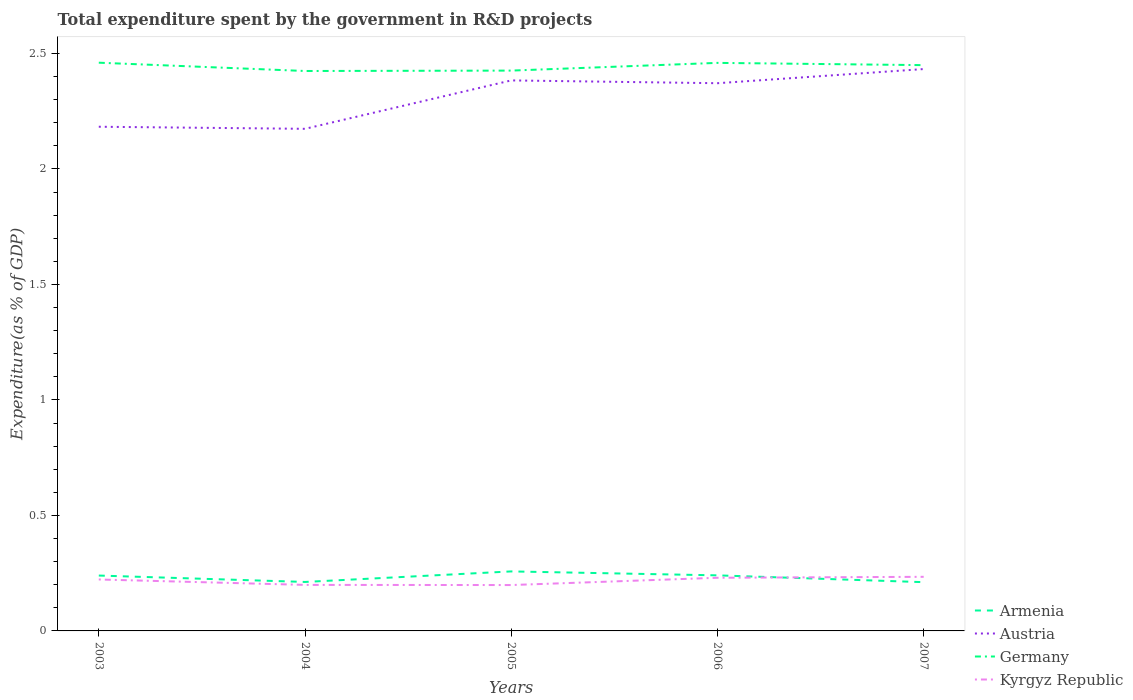How many different coloured lines are there?
Provide a succinct answer. 4. Does the line corresponding to Armenia intersect with the line corresponding to Kyrgyz Republic?
Give a very brief answer. Yes. Across all years, what is the maximum total expenditure spent by the government in R&D projects in Germany?
Give a very brief answer. 2.42. What is the total total expenditure spent by the government in R&D projects in Austria in the graph?
Your answer should be very brief. -0.25. What is the difference between the highest and the second highest total expenditure spent by the government in R&D projects in Kyrgyz Republic?
Your answer should be very brief. 0.04. Does the graph contain any zero values?
Your answer should be compact. No. Does the graph contain grids?
Provide a short and direct response. No. Where does the legend appear in the graph?
Give a very brief answer. Bottom right. What is the title of the graph?
Provide a succinct answer. Total expenditure spent by the government in R&D projects. Does "Thailand" appear as one of the legend labels in the graph?
Ensure brevity in your answer.  No. What is the label or title of the Y-axis?
Offer a terse response. Expenditure(as % of GDP). What is the Expenditure(as % of GDP) of Armenia in 2003?
Your answer should be compact. 0.24. What is the Expenditure(as % of GDP) of Austria in 2003?
Make the answer very short. 2.18. What is the Expenditure(as % of GDP) in Germany in 2003?
Provide a succinct answer. 2.46. What is the Expenditure(as % of GDP) of Kyrgyz Republic in 2003?
Your response must be concise. 0.22. What is the Expenditure(as % of GDP) of Armenia in 2004?
Provide a succinct answer. 0.21. What is the Expenditure(as % of GDP) in Austria in 2004?
Your answer should be compact. 2.17. What is the Expenditure(as % of GDP) of Germany in 2004?
Make the answer very short. 2.42. What is the Expenditure(as % of GDP) of Kyrgyz Republic in 2004?
Your answer should be compact. 0.2. What is the Expenditure(as % of GDP) of Armenia in 2005?
Offer a very short reply. 0.26. What is the Expenditure(as % of GDP) of Austria in 2005?
Give a very brief answer. 2.38. What is the Expenditure(as % of GDP) in Germany in 2005?
Offer a very short reply. 2.43. What is the Expenditure(as % of GDP) in Kyrgyz Republic in 2005?
Your answer should be compact. 0.2. What is the Expenditure(as % of GDP) of Armenia in 2006?
Provide a succinct answer. 0.24. What is the Expenditure(as % of GDP) in Austria in 2006?
Provide a succinct answer. 2.37. What is the Expenditure(as % of GDP) of Germany in 2006?
Provide a succinct answer. 2.46. What is the Expenditure(as % of GDP) in Kyrgyz Republic in 2006?
Give a very brief answer. 0.23. What is the Expenditure(as % of GDP) in Armenia in 2007?
Your answer should be compact. 0.21. What is the Expenditure(as % of GDP) of Austria in 2007?
Offer a very short reply. 2.43. What is the Expenditure(as % of GDP) of Germany in 2007?
Give a very brief answer. 2.45. What is the Expenditure(as % of GDP) of Kyrgyz Republic in 2007?
Provide a succinct answer. 0.23. Across all years, what is the maximum Expenditure(as % of GDP) in Armenia?
Provide a succinct answer. 0.26. Across all years, what is the maximum Expenditure(as % of GDP) in Austria?
Provide a succinct answer. 2.43. Across all years, what is the maximum Expenditure(as % of GDP) in Germany?
Your answer should be very brief. 2.46. Across all years, what is the maximum Expenditure(as % of GDP) in Kyrgyz Republic?
Your answer should be very brief. 0.23. Across all years, what is the minimum Expenditure(as % of GDP) in Armenia?
Your answer should be compact. 0.21. Across all years, what is the minimum Expenditure(as % of GDP) in Austria?
Keep it short and to the point. 2.17. Across all years, what is the minimum Expenditure(as % of GDP) of Germany?
Provide a succinct answer. 2.42. Across all years, what is the minimum Expenditure(as % of GDP) in Kyrgyz Republic?
Ensure brevity in your answer.  0.2. What is the total Expenditure(as % of GDP) of Armenia in the graph?
Offer a very short reply. 1.16. What is the total Expenditure(as % of GDP) of Austria in the graph?
Ensure brevity in your answer.  11.54. What is the total Expenditure(as % of GDP) of Germany in the graph?
Offer a very short reply. 12.22. What is the total Expenditure(as % of GDP) of Kyrgyz Republic in the graph?
Make the answer very short. 1.08. What is the difference between the Expenditure(as % of GDP) in Armenia in 2003 and that in 2004?
Your response must be concise. 0.03. What is the difference between the Expenditure(as % of GDP) in Austria in 2003 and that in 2004?
Offer a terse response. 0.01. What is the difference between the Expenditure(as % of GDP) of Germany in 2003 and that in 2004?
Ensure brevity in your answer.  0.04. What is the difference between the Expenditure(as % of GDP) of Kyrgyz Republic in 2003 and that in 2004?
Provide a short and direct response. 0.02. What is the difference between the Expenditure(as % of GDP) in Armenia in 2003 and that in 2005?
Provide a short and direct response. -0.02. What is the difference between the Expenditure(as % of GDP) of Austria in 2003 and that in 2005?
Give a very brief answer. -0.2. What is the difference between the Expenditure(as % of GDP) of Germany in 2003 and that in 2005?
Offer a terse response. 0.03. What is the difference between the Expenditure(as % of GDP) of Kyrgyz Republic in 2003 and that in 2005?
Offer a very short reply. 0.02. What is the difference between the Expenditure(as % of GDP) of Armenia in 2003 and that in 2006?
Provide a short and direct response. -0. What is the difference between the Expenditure(as % of GDP) of Austria in 2003 and that in 2006?
Your answer should be very brief. -0.19. What is the difference between the Expenditure(as % of GDP) in Germany in 2003 and that in 2006?
Ensure brevity in your answer.  0. What is the difference between the Expenditure(as % of GDP) in Kyrgyz Republic in 2003 and that in 2006?
Your response must be concise. -0.01. What is the difference between the Expenditure(as % of GDP) of Armenia in 2003 and that in 2007?
Offer a very short reply. 0.03. What is the difference between the Expenditure(as % of GDP) in Austria in 2003 and that in 2007?
Give a very brief answer. -0.25. What is the difference between the Expenditure(as % of GDP) of Germany in 2003 and that in 2007?
Provide a short and direct response. 0.01. What is the difference between the Expenditure(as % of GDP) in Kyrgyz Republic in 2003 and that in 2007?
Your answer should be compact. -0.01. What is the difference between the Expenditure(as % of GDP) in Armenia in 2004 and that in 2005?
Your response must be concise. -0.05. What is the difference between the Expenditure(as % of GDP) of Austria in 2004 and that in 2005?
Offer a very short reply. -0.21. What is the difference between the Expenditure(as % of GDP) of Germany in 2004 and that in 2005?
Make the answer very short. -0. What is the difference between the Expenditure(as % of GDP) in Kyrgyz Republic in 2004 and that in 2005?
Offer a terse response. 0. What is the difference between the Expenditure(as % of GDP) of Armenia in 2004 and that in 2006?
Provide a short and direct response. -0.03. What is the difference between the Expenditure(as % of GDP) in Austria in 2004 and that in 2006?
Make the answer very short. -0.2. What is the difference between the Expenditure(as % of GDP) in Germany in 2004 and that in 2006?
Offer a very short reply. -0.04. What is the difference between the Expenditure(as % of GDP) in Kyrgyz Republic in 2004 and that in 2006?
Make the answer very short. -0.03. What is the difference between the Expenditure(as % of GDP) in Armenia in 2004 and that in 2007?
Your answer should be very brief. 0. What is the difference between the Expenditure(as % of GDP) in Austria in 2004 and that in 2007?
Provide a short and direct response. -0.26. What is the difference between the Expenditure(as % of GDP) of Germany in 2004 and that in 2007?
Ensure brevity in your answer.  -0.03. What is the difference between the Expenditure(as % of GDP) of Kyrgyz Republic in 2004 and that in 2007?
Provide a short and direct response. -0.04. What is the difference between the Expenditure(as % of GDP) in Armenia in 2005 and that in 2006?
Make the answer very short. 0.02. What is the difference between the Expenditure(as % of GDP) in Austria in 2005 and that in 2006?
Ensure brevity in your answer.  0.01. What is the difference between the Expenditure(as % of GDP) of Germany in 2005 and that in 2006?
Provide a short and direct response. -0.03. What is the difference between the Expenditure(as % of GDP) in Kyrgyz Republic in 2005 and that in 2006?
Give a very brief answer. -0.03. What is the difference between the Expenditure(as % of GDP) of Armenia in 2005 and that in 2007?
Your answer should be very brief. 0.05. What is the difference between the Expenditure(as % of GDP) in Austria in 2005 and that in 2007?
Ensure brevity in your answer.  -0.05. What is the difference between the Expenditure(as % of GDP) of Germany in 2005 and that in 2007?
Provide a succinct answer. -0.02. What is the difference between the Expenditure(as % of GDP) of Kyrgyz Republic in 2005 and that in 2007?
Make the answer very short. -0.04. What is the difference between the Expenditure(as % of GDP) of Armenia in 2006 and that in 2007?
Offer a terse response. 0.03. What is the difference between the Expenditure(as % of GDP) in Austria in 2006 and that in 2007?
Your answer should be very brief. -0.06. What is the difference between the Expenditure(as % of GDP) in Germany in 2006 and that in 2007?
Ensure brevity in your answer.  0.01. What is the difference between the Expenditure(as % of GDP) in Kyrgyz Republic in 2006 and that in 2007?
Make the answer very short. -0. What is the difference between the Expenditure(as % of GDP) in Armenia in 2003 and the Expenditure(as % of GDP) in Austria in 2004?
Your answer should be very brief. -1.93. What is the difference between the Expenditure(as % of GDP) of Armenia in 2003 and the Expenditure(as % of GDP) of Germany in 2004?
Offer a very short reply. -2.18. What is the difference between the Expenditure(as % of GDP) in Armenia in 2003 and the Expenditure(as % of GDP) in Kyrgyz Republic in 2004?
Your answer should be compact. 0.04. What is the difference between the Expenditure(as % of GDP) of Austria in 2003 and the Expenditure(as % of GDP) of Germany in 2004?
Offer a terse response. -0.24. What is the difference between the Expenditure(as % of GDP) in Austria in 2003 and the Expenditure(as % of GDP) in Kyrgyz Republic in 2004?
Offer a terse response. 1.98. What is the difference between the Expenditure(as % of GDP) in Germany in 2003 and the Expenditure(as % of GDP) in Kyrgyz Republic in 2004?
Offer a very short reply. 2.26. What is the difference between the Expenditure(as % of GDP) in Armenia in 2003 and the Expenditure(as % of GDP) in Austria in 2005?
Make the answer very short. -2.14. What is the difference between the Expenditure(as % of GDP) of Armenia in 2003 and the Expenditure(as % of GDP) of Germany in 2005?
Provide a succinct answer. -2.19. What is the difference between the Expenditure(as % of GDP) in Armenia in 2003 and the Expenditure(as % of GDP) in Kyrgyz Republic in 2005?
Offer a terse response. 0.04. What is the difference between the Expenditure(as % of GDP) in Austria in 2003 and the Expenditure(as % of GDP) in Germany in 2005?
Your response must be concise. -0.24. What is the difference between the Expenditure(as % of GDP) of Austria in 2003 and the Expenditure(as % of GDP) of Kyrgyz Republic in 2005?
Give a very brief answer. 1.98. What is the difference between the Expenditure(as % of GDP) in Germany in 2003 and the Expenditure(as % of GDP) in Kyrgyz Republic in 2005?
Ensure brevity in your answer.  2.26. What is the difference between the Expenditure(as % of GDP) of Armenia in 2003 and the Expenditure(as % of GDP) of Austria in 2006?
Ensure brevity in your answer.  -2.13. What is the difference between the Expenditure(as % of GDP) of Armenia in 2003 and the Expenditure(as % of GDP) of Germany in 2006?
Provide a succinct answer. -2.22. What is the difference between the Expenditure(as % of GDP) in Armenia in 2003 and the Expenditure(as % of GDP) in Kyrgyz Republic in 2006?
Offer a terse response. 0.01. What is the difference between the Expenditure(as % of GDP) in Austria in 2003 and the Expenditure(as % of GDP) in Germany in 2006?
Give a very brief answer. -0.28. What is the difference between the Expenditure(as % of GDP) of Austria in 2003 and the Expenditure(as % of GDP) of Kyrgyz Republic in 2006?
Your response must be concise. 1.95. What is the difference between the Expenditure(as % of GDP) in Germany in 2003 and the Expenditure(as % of GDP) in Kyrgyz Republic in 2006?
Make the answer very short. 2.23. What is the difference between the Expenditure(as % of GDP) of Armenia in 2003 and the Expenditure(as % of GDP) of Austria in 2007?
Your answer should be very brief. -2.19. What is the difference between the Expenditure(as % of GDP) in Armenia in 2003 and the Expenditure(as % of GDP) in Germany in 2007?
Keep it short and to the point. -2.21. What is the difference between the Expenditure(as % of GDP) in Armenia in 2003 and the Expenditure(as % of GDP) in Kyrgyz Republic in 2007?
Offer a terse response. 0.01. What is the difference between the Expenditure(as % of GDP) in Austria in 2003 and the Expenditure(as % of GDP) in Germany in 2007?
Give a very brief answer. -0.27. What is the difference between the Expenditure(as % of GDP) of Austria in 2003 and the Expenditure(as % of GDP) of Kyrgyz Republic in 2007?
Offer a very short reply. 1.95. What is the difference between the Expenditure(as % of GDP) in Germany in 2003 and the Expenditure(as % of GDP) in Kyrgyz Republic in 2007?
Provide a short and direct response. 2.23. What is the difference between the Expenditure(as % of GDP) in Armenia in 2004 and the Expenditure(as % of GDP) in Austria in 2005?
Your answer should be very brief. -2.17. What is the difference between the Expenditure(as % of GDP) of Armenia in 2004 and the Expenditure(as % of GDP) of Germany in 2005?
Your answer should be compact. -2.21. What is the difference between the Expenditure(as % of GDP) of Armenia in 2004 and the Expenditure(as % of GDP) of Kyrgyz Republic in 2005?
Ensure brevity in your answer.  0.01. What is the difference between the Expenditure(as % of GDP) in Austria in 2004 and the Expenditure(as % of GDP) in Germany in 2005?
Keep it short and to the point. -0.25. What is the difference between the Expenditure(as % of GDP) in Austria in 2004 and the Expenditure(as % of GDP) in Kyrgyz Republic in 2005?
Make the answer very short. 1.98. What is the difference between the Expenditure(as % of GDP) of Germany in 2004 and the Expenditure(as % of GDP) of Kyrgyz Republic in 2005?
Offer a very short reply. 2.23. What is the difference between the Expenditure(as % of GDP) in Armenia in 2004 and the Expenditure(as % of GDP) in Austria in 2006?
Your answer should be compact. -2.16. What is the difference between the Expenditure(as % of GDP) in Armenia in 2004 and the Expenditure(as % of GDP) in Germany in 2006?
Provide a short and direct response. -2.25. What is the difference between the Expenditure(as % of GDP) of Armenia in 2004 and the Expenditure(as % of GDP) of Kyrgyz Republic in 2006?
Your answer should be compact. -0.02. What is the difference between the Expenditure(as % of GDP) in Austria in 2004 and the Expenditure(as % of GDP) in Germany in 2006?
Ensure brevity in your answer.  -0.29. What is the difference between the Expenditure(as % of GDP) in Austria in 2004 and the Expenditure(as % of GDP) in Kyrgyz Republic in 2006?
Give a very brief answer. 1.94. What is the difference between the Expenditure(as % of GDP) of Germany in 2004 and the Expenditure(as % of GDP) of Kyrgyz Republic in 2006?
Make the answer very short. 2.19. What is the difference between the Expenditure(as % of GDP) in Armenia in 2004 and the Expenditure(as % of GDP) in Austria in 2007?
Provide a succinct answer. -2.22. What is the difference between the Expenditure(as % of GDP) in Armenia in 2004 and the Expenditure(as % of GDP) in Germany in 2007?
Give a very brief answer. -2.24. What is the difference between the Expenditure(as % of GDP) of Armenia in 2004 and the Expenditure(as % of GDP) of Kyrgyz Republic in 2007?
Make the answer very short. -0.02. What is the difference between the Expenditure(as % of GDP) of Austria in 2004 and the Expenditure(as % of GDP) of Germany in 2007?
Your response must be concise. -0.28. What is the difference between the Expenditure(as % of GDP) of Austria in 2004 and the Expenditure(as % of GDP) of Kyrgyz Republic in 2007?
Your answer should be compact. 1.94. What is the difference between the Expenditure(as % of GDP) of Germany in 2004 and the Expenditure(as % of GDP) of Kyrgyz Republic in 2007?
Make the answer very short. 2.19. What is the difference between the Expenditure(as % of GDP) of Armenia in 2005 and the Expenditure(as % of GDP) of Austria in 2006?
Your answer should be compact. -2.11. What is the difference between the Expenditure(as % of GDP) of Armenia in 2005 and the Expenditure(as % of GDP) of Germany in 2006?
Ensure brevity in your answer.  -2.2. What is the difference between the Expenditure(as % of GDP) in Armenia in 2005 and the Expenditure(as % of GDP) in Kyrgyz Republic in 2006?
Provide a short and direct response. 0.03. What is the difference between the Expenditure(as % of GDP) in Austria in 2005 and the Expenditure(as % of GDP) in Germany in 2006?
Keep it short and to the point. -0.08. What is the difference between the Expenditure(as % of GDP) in Austria in 2005 and the Expenditure(as % of GDP) in Kyrgyz Republic in 2006?
Make the answer very short. 2.15. What is the difference between the Expenditure(as % of GDP) in Germany in 2005 and the Expenditure(as % of GDP) in Kyrgyz Republic in 2006?
Offer a very short reply. 2.2. What is the difference between the Expenditure(as % of GDP) in Armenia in 2005 and the Expenditure(as % of GDP) in Austria in 2007?
Keep it short and to the point. -2.17. What is the difference between the Expenditure(as % of GDP) in Armenia in 2005 and the Expenditure(as % of GDP) in Germany in 2007?
Your answer should be very brief. -2.19. What is the difference between the Expenditure(as % of GDP) of Armenia in 2005 and the Expenditure(as % of GDP) of Kyrgyz Republic in 2007?
Your answer should be compact. 0.02. What is the difference between the Expenditure(as % of GDP) in Austria in 2005 and the Expenditure(as % of GDP) in Germany in 2007?
Your response must be concise. -0.07. What is the difference between the Expenditure(as % of GDP) in Austria in 2005 and the Expenditure(as % of GDP) in Kyrgyz Republic in 2007?
Ensure brevity in your answer.  2.15. What is the difference between the Expenditure(as % of GDP) of Germany in 2005 and the Expenditure(as % of GDP) of Kyrgyz Republic in 2007?
Your answer should be compact. 2.19. What is the difference between the Expenditure(as % of GDP) of Armenia in 2006 and the Expenditure(as % of GDP) of Austria in 2007?
Offer a very short reply. -2.19. What is the difference between the Expenditure(as % of GDP) in Armenia in 2006 and the Expenditure(as % of GDP) in Germany in 2007?
Your answer should be very brief. -2.21. What is the difference between the Expenditure(as % of GDP) in Armenia in 2006 and the Expenditure(as % of GDP) in Kyrgyz Republic in 2007?
Your answer should be compact. 0.01. What is the difference between the Expenditure(as % of GDP) in Austria in 2006 and the Expenditure(as % of GDP) in Germany in 2007?
Keep it short and to the point. -0.08. What is the difference between the Expenditure(as % of GDP) of Austria in 2006 and the Expenditure(as % of GDP) of Kyrgyz Republic in 2007?
Provide a succinct answer. 2.14. What is the difference between the Expenditure(as % of GDP) in Germany in 2006 and the Expenditure(as % of GDP) in Kyrgyz Republic in 2007?
Your answer should be compact. 2.22. What is the average Expenditure(as % of GDP) of Armenia per year?
Ensure brevity in your answer.  0.23. What is the average Expenditure(as % of GDP) of Austria per year?
Make the answer very short. 2.31. What is the average Expenditure(as % of GDP) of Germany per year?
Keep it short and to the point. 2.44. What is the average Expenditure(as % of GDP) in Kyrgyz Republic per year?
Offer a very short reply. 0.22. In the year 2003, what is the difference between the Expenditure(as % of GDP) in Armenia and Expenditure(as % of GDP) in Austria?
Your answer should be compact. -1.94. In the year 2003, what is the difference between the Expenditure(as % of GDP) of Armenia and Expenditure(as % of GDP) of Germany?
Ensure brevity in your answer.  -2.22. In the year 2003, what is the difference between the Expenditure(as % of GDP) of Armenia and Expenditure(as % of GDP) of Kyrgyz Republic?
Your answer should be very brief. 0.02. In the year 2003, what is the difference between the Expenditure(as % of GDP) in Austria and Expenditure(as % of GDP) in Germany?
Offer a very short reply. -0.28. In the year 2003, what is the difference between the Expenditure(as % of GDP) of Austria and Expenditure(as % of GDP) of Kyrgyz Republic?
Provide a short and direct response. 1.96. In the year 2003, what is the difference between the Expenditure(as % of GDP) of Germany and Expenditure(as % of GDP) of Kyrgyz Republic?
Offer a terse response. 2.24. In the year 2004, what is the difference between the Expenditure(as % of GDP) of Armenia and Expenditure(as % of GDP) of Austria?
Make the answer very short. -1.96. In the year 2004, what is the difference between the Expenditure(as % of GDP) of Armenia and Expenditure(as % of GDP) of Germany?
Ensure brevity in your answer.  -2.21. In the year 2004, what is the difference between the Expenditure(as % of GDP) in Armenia and Expenditure(as % of GDP) in Kyrgyz Republic?
Make the answer very short. 0.01. In the year 2004, what is the difference between the Expenditure(as % of GDP) of Austria and Expenditure(as % of GDP) of Germany?
Offer a very short reply. -0.25. In the year 2004, what is the difference between the Expenditure(as % of GDP) of Austria and Expenditure(as % of GDP) of Kyrgyz Republic?
Give a very brief answer. 1.97. In the year 2004, what is the difference between the Expenditure(as % of GDP) of Germany and Expenditure(as % of GDP) of Kyrgyz Republic?
Offer a very short reply. 2.22. In the year 2005, what is the difference between the Expenditure(as % of GDP) of Armenia and Expenditure(as % of GDP) of Austria?
Make the answer very short. -2.13. In the year 2005, what is the difference between the Expenditure(as % of GDP) of Armenia and Expenditure(as % of GDP) of Germany?
Keep it short and to the point. -2.17. In the year 2005, what is the difference between the Expenditure(as % of GDP) in Armenia and Expenditure(as % of GDP) in Kyrgyz Republic?
Make the answer very short. 0.06. In the year 2005, what is the difference between the Expenditure(as % of GDP) in Austria and Expenditure(as % of GDP) in Germany?
Offer a terse response. -0.04. In the year 2005, what is the difference between the Expenditure(as % of GDP) of Austria and Expenditure(as % of GDP) of Kyrgyz Republic?
Make the answer very short. 2.18. In the year 2005, what is the difference between the Expenditure(as % of GDP) in Germany and Expenditure(as % of GDP) in Kyrgyz Republic?
Your response must be concise. 2.23. In the year 2006, what is the difference between the Expenditure(as % of GDP) in Armenia and Expenditure(as % of GDP) in Austria?
Ensure brevity in your answer.  -2.13. In the year 2006, what is the difference between the Expenditure(as % of GDP) in Armenia and Expenditure(as % of GDP) in Germany?
Give a very brief answer. -2.22. In the year 2006, what is the difference between the Expenditure(as % of GDP) of Armenia and Expenditure(as % of GDP) of Kyrgyz Republic?
Your answer should be very brief. 0.01. In the year 2006, what is the difference between the Expenditure(as % of GDP) of Austria and Expenditure(as % of GDP) of Germany?
Offer a terse response. -0.09. In the year 2006, what is the difference between the Expenditure(as % of GDP) in Austria and Expenditure(as % of GDP) in Kyrgyz Republic?
Offer a very short reply. 2.14. In the year 2006, what is the difference between the Expenditure(as % of GDP) in Germany and Expenditure(as % of GDP) in Kyrgyz Republic?
Provide a succinct answer. 2.23. In the year 2007, what is the difference between the Expenditure(as % of GDP) of Armenia and Expenditure(as % of GDP) of Austria?
Your answer should be very brief. -2.22. In the year 2007, what is the difference between the Expenditure(as % of GDP) in Armenia and Expenditure(as % of GDP) in Germany?
Offer a very short reply. -2.24. In the year 2007, what is the difference between the Expenditure(as % of GDP) of Armenia and Expenditure(as % of GDP) of Kyrgyz Republic?
Your response must be concise. -0.02. In the year 2007, what is the difference between the Expenditure(as % of GDP) in Austria and Expenditure(as % of GDP) in Germany?
Give a very brief answer. -0.02. In the year 2007, what is the difference between the Expenditure(as % of GDP) of Austria and Expenditure(as % of GDP) of Kyrgyz Republic?
Your answer should be compact. 2.2. In the year 2007, what is the difference between the Expenditure(as % of GDP) of Germany and Expenditure(as % of GDP) of Kyrgyz Republic?
Ensure brevity in your answer.  2.22. What is the ratio of the Expenditure(as % of GDP) in Armenia in 2003 to that in 2004?
Offer a terse response. 1.13. What is the ratio of the Expenditure(as % of GDP) in Germany in 2003 to that in 2004?
Your answer should be very brief. 1.01. What is the ratio of the Expenditure(as % of GDP) of Kyrgyz Republic in 2003 to that in 2004?
Offer a terse response. 1.12. What is the ratio of the Expenditure(as % of GDP) in Armenia in 2003 to that in 2005?
Provide a short and direct response. 0.93. What is the ratio of the Expenditure(as % of GDP) in Austria in 2003 to that in 2005?
Your answer should be compact. 0.92. What is the ratio of the Expenditure(as % of GDP) of Germany in 2003 to that in 2005?
Your response must be concise. 1.01. What is the ratio of the Expenditure(as % of GDP) in Kyrgyz Republic in 2003 to that in 2005?
Keep it short and to the point. 1.12. What is the ratio of the Expenditure(as % of GDP) of Austria in 2003 to that in 2006?
Offer a very short reply. 0.92. What is the ratio of the Expenditure(as % of GDP) in Kyrgyz Republic in 2003 to that in 2006?
Keep it short and to the point. 0.97. What is the ratio of the Expenditure(as % of GDP) in Armenia in 2003 to that in 2007?
Your response must be concise. 1.14. What is the ratio of the Expenditure(as % of GDP) of Austria in 2003 to that in 2007?
Ensure brevity in your answer.  0.9. What is the ratio of the Expenditure(as % of GDP) of Kyrgyz Republic in 2003 to that in 2007?
Your answer should be very brief. 0.95. What is the ratio of the Expenditure(as % of GDP) of Armenia in 2004 to that in 2005?
Your answer should be very brief. 0.82. What is the ratio of the Expenditure(as % of GDP) in Austria in 2004 to that in 2005?
Ensure brevity in your answer.  0.91. What is the ratio of the Expenditure(as % of GDP) in Kyrgyz Republic in 2004 to that in 2005?
Make the answer very short. 1. What is the ratio of the Expenditure(as % of GDP) in Armenia in 2004 to that in 2006?
Make the answer very short. 0.88. What is the ratio of the Expenditure(as % of GDP) of Austria in 2004 to that in 2006?
Provide a short and direct response. 0.92. What is the ratio of the Expenditure(as % of GDP) of Germany in 2004 to that in 2006?
Your answer should be compact. 0.99. What is the ratio of the Expenditure(as % of GDP) of Kyrgyz Republic in 2004 to that in 2006?
Give a very brief answer. 0.87. What is the ratio of the Expenditure(as % of GDP) of Armenia in 2004 to that in 2007?
Your response must be concise. 1. What is the ratio of the Expenditure(as % of GDP) in Austria in 2004 to that in 2007?
Your answer should be compact. 0.89. What is the ratio of the Expenditure(as % of GDP) of Germany in 2004 to that in 2007?
Your response must be concise. 0.99. What is the ratio of the Expenditure(as % of GDP) in Kyrgyz Republic in 2004 to that in 2007?
Give a very brief answer. 0.85. What is the ratio of the Expenditure(as % of GDP) of Armenia in 2005 to that in 2006?
Provide a short and direct response. 1.07. What is the ratio of the Expenditure(as % of GDP) in Germany in 2005 to that in 2006?
Your response must be concise. 0.99. What is the ratio of the Expenditure(as % of GDP) of Kyrgyz Republic in 2005 to that in 2006?
Provide a short and direct response. 0.86. What is the ratio of the Expenditure(as % of GDP) in Armenia in 2005 to that in 2007?
Ensure brevity in your answer.  1.22. What is the ratio of the Expenditure(as % of GDP) in Austria in 2005 to that in 2007?
Provide a succinct answer. 0.98. What is the ratio of the Expenditure(as % of GDP) in Kyrgyz Republic in 2005 to that in 2007?
Your response must be concise. 0.85. What is the ratio of the Expenditure(as % of GDP) of Armenia in 2006 to that in 2007?
Your response must be concise. 1.14. What is the ratio of the Expenditure(as % of GDP) of Austria in 2006 to that in 2007?
Your response must be concise. 0.97. What is the ratio of the Expenditure(as % of GDP) in Germany in 2006 to that in 2007?
Offer a terse response. 1. What is the ratio of the Expenditure(as % of GDP) in Kyrgyz Republic in 2006 to that in 2007?
Ensure brevity in your answer.  0.98. What is the difference between the highest and the second highest Expenditure(as % of GDP) of Armenia?
Keep it short and to the point. 0.02. What is the difference between the highest and the second highest Expenditure(as % of GDP) in Austria?
Offer a terse response. 0.05. What is the difference between the highest and the second highest Expenditure(as % of GDP) of Germany?
Give a very brief answer. 0. What is the difference between the highest and the second highest Expenditure(as % of GDP) of Kyrgyz Republic?
Offer a very short reply. 0. What is the difference between the highest and the lowest Expenditure(as % of GDP) in Armenia?
Offer a terse response. 0.05. What is the difference between the highest and the lowest Expenditure(as % of GDP) in Austria?
Give a very brief answer. 0.26. What is the difference between the highest and the lowest Expenditure(as % of GDP) of Germany?
Offer a very short reply. 0.04. What is the difference between the highest and the lowest Expenditure(as % of GDP) of Kyrgyz Republic?
Ensure brevity in your answer.  0.04. 